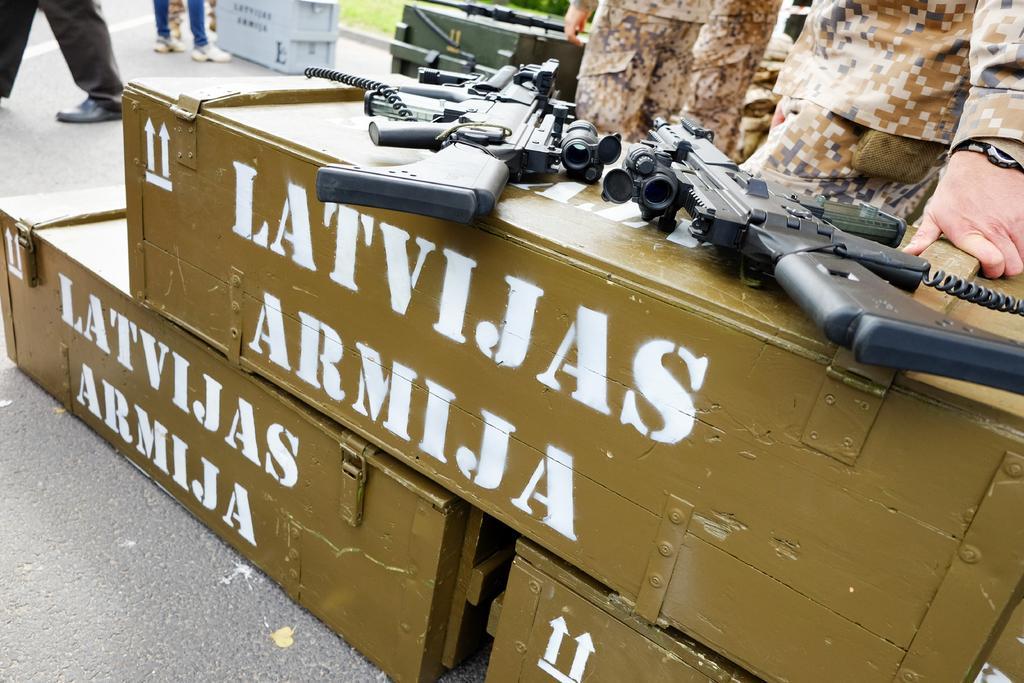How would you summarize this image in a sentence or two? In the foreground of this image, there are three boxes on which two guns are placed. In the background, there are few persons standing, boxes, and the guns. 